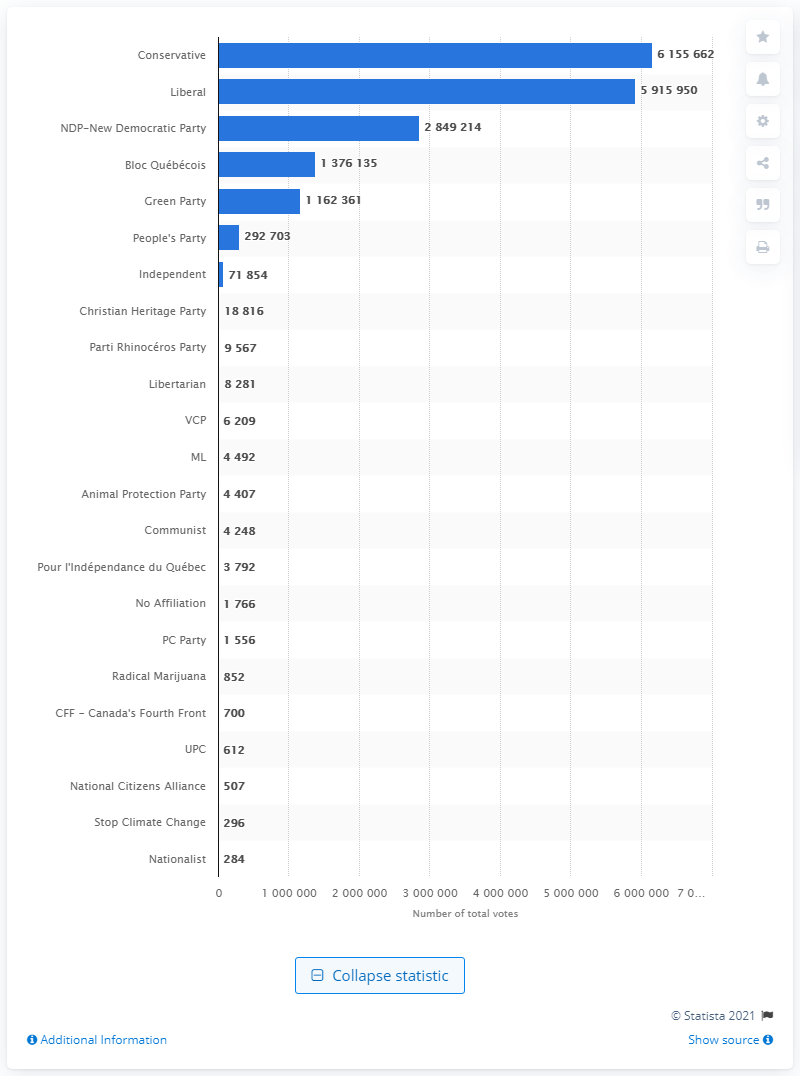Mention a couple of crucial points in this snapshot. In the 2019 federal election, the Conservative Party received a total of 61,556,212 votes. The Liberal Party received 59,159,500 votes in the 2019 election. 